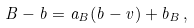<formula> <loc_0><loc_0><loc_500><loc_500>B - b = a _ { B } ( b - v ) + b _ { B } \, , \,</formula> 